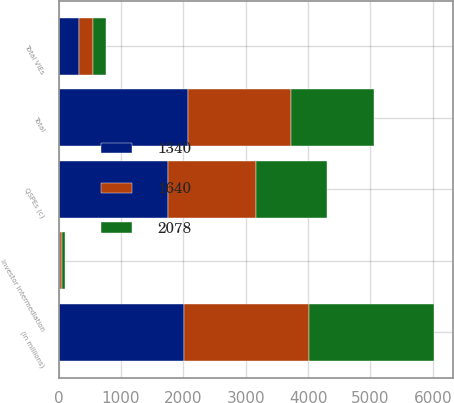<chart> <loc_0><loc_0><loc_500><loc_500><stacked_bar_chart><ecel><fcel>(in millions)<fcel>Investor intermediation<fcel>Total VIEs<fcel>QSPEs (c)<fcel>Total<nl><fcel>1340<fcel>2008<fcel>18<fcel>332<fcel>1746<fcel>2078<nl><fcel>1640<fcel>2007<fcel>33<fcel>220<fcel>1420<fcel>1640<nl><fcel>2078<fcel>2006<fcel>49<fcel>209<fcel>1131<fcel>1340<nl></chart> 